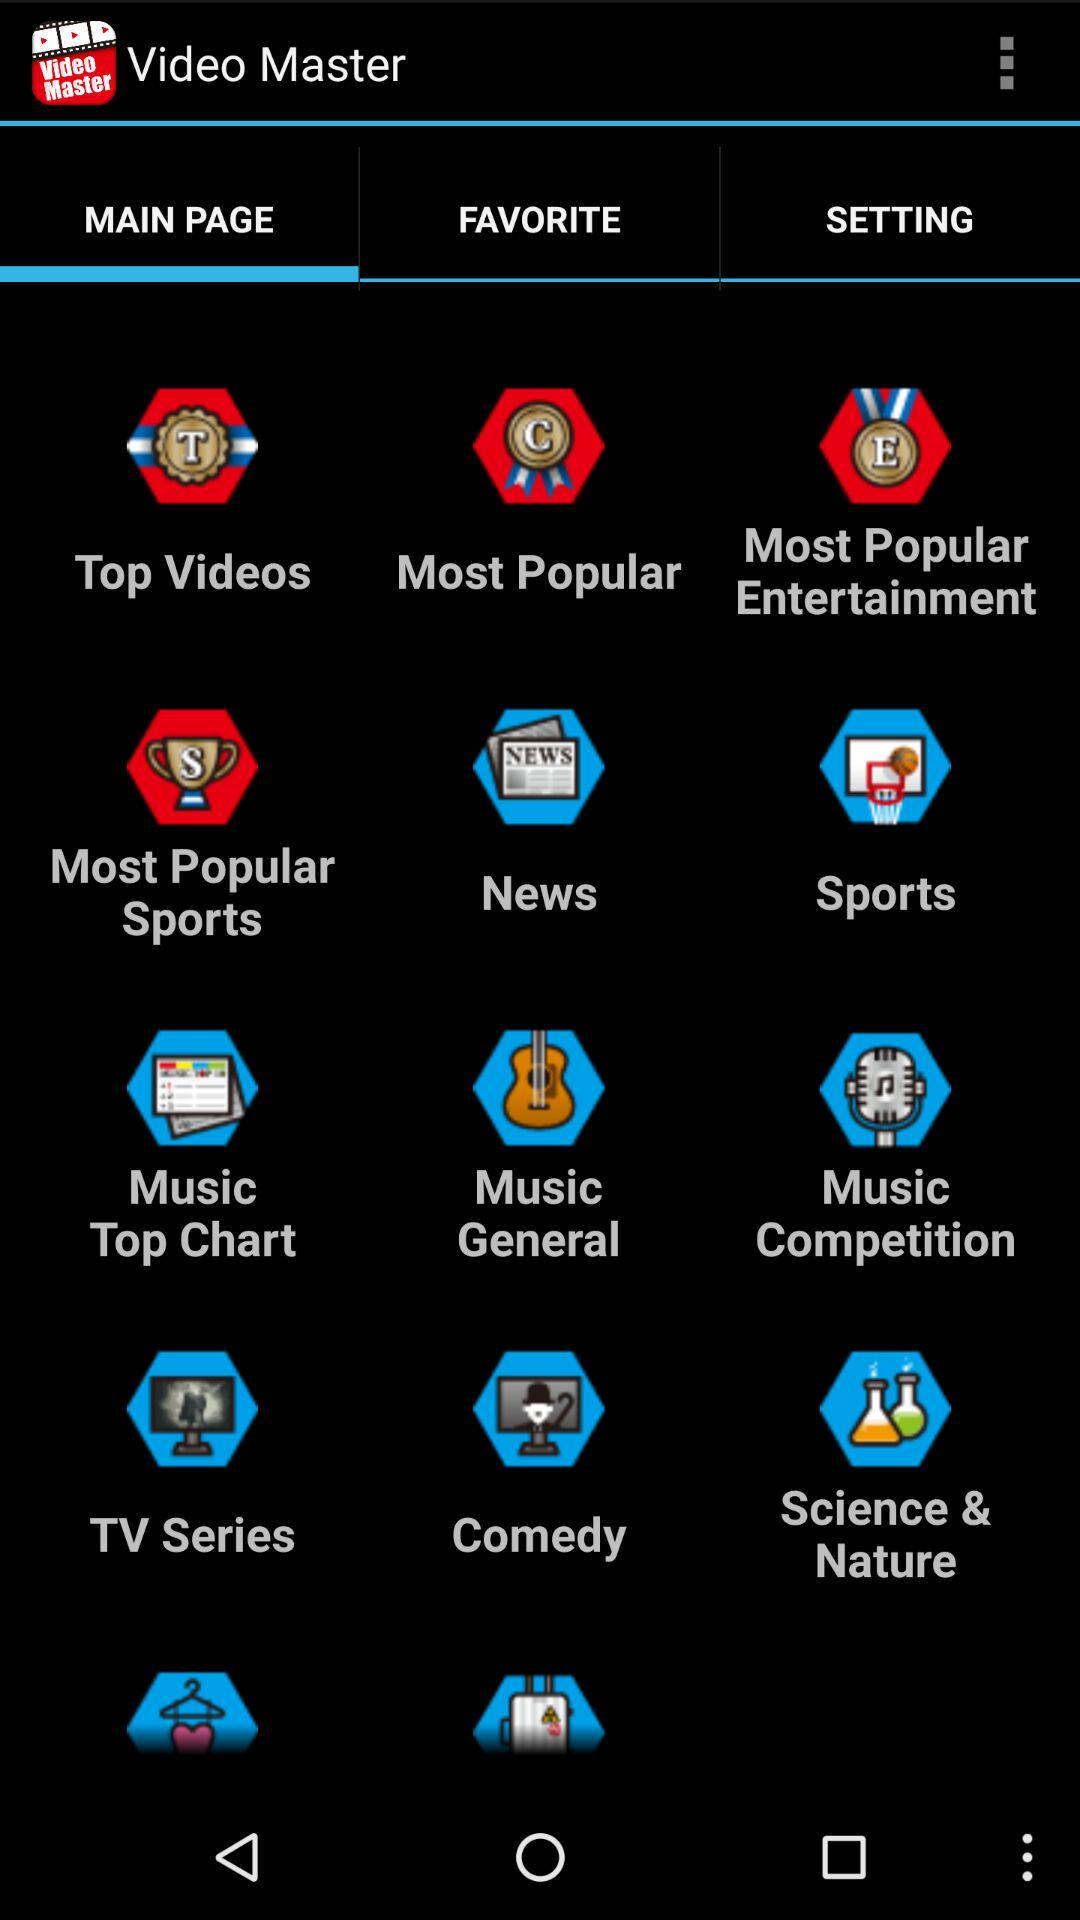What is the name of the application? The name of the application is "Video Master". 